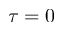Convert formula to latex. <formula><loc_0><loc_0><loc_500><loc_500>\tau = 0</formula> 